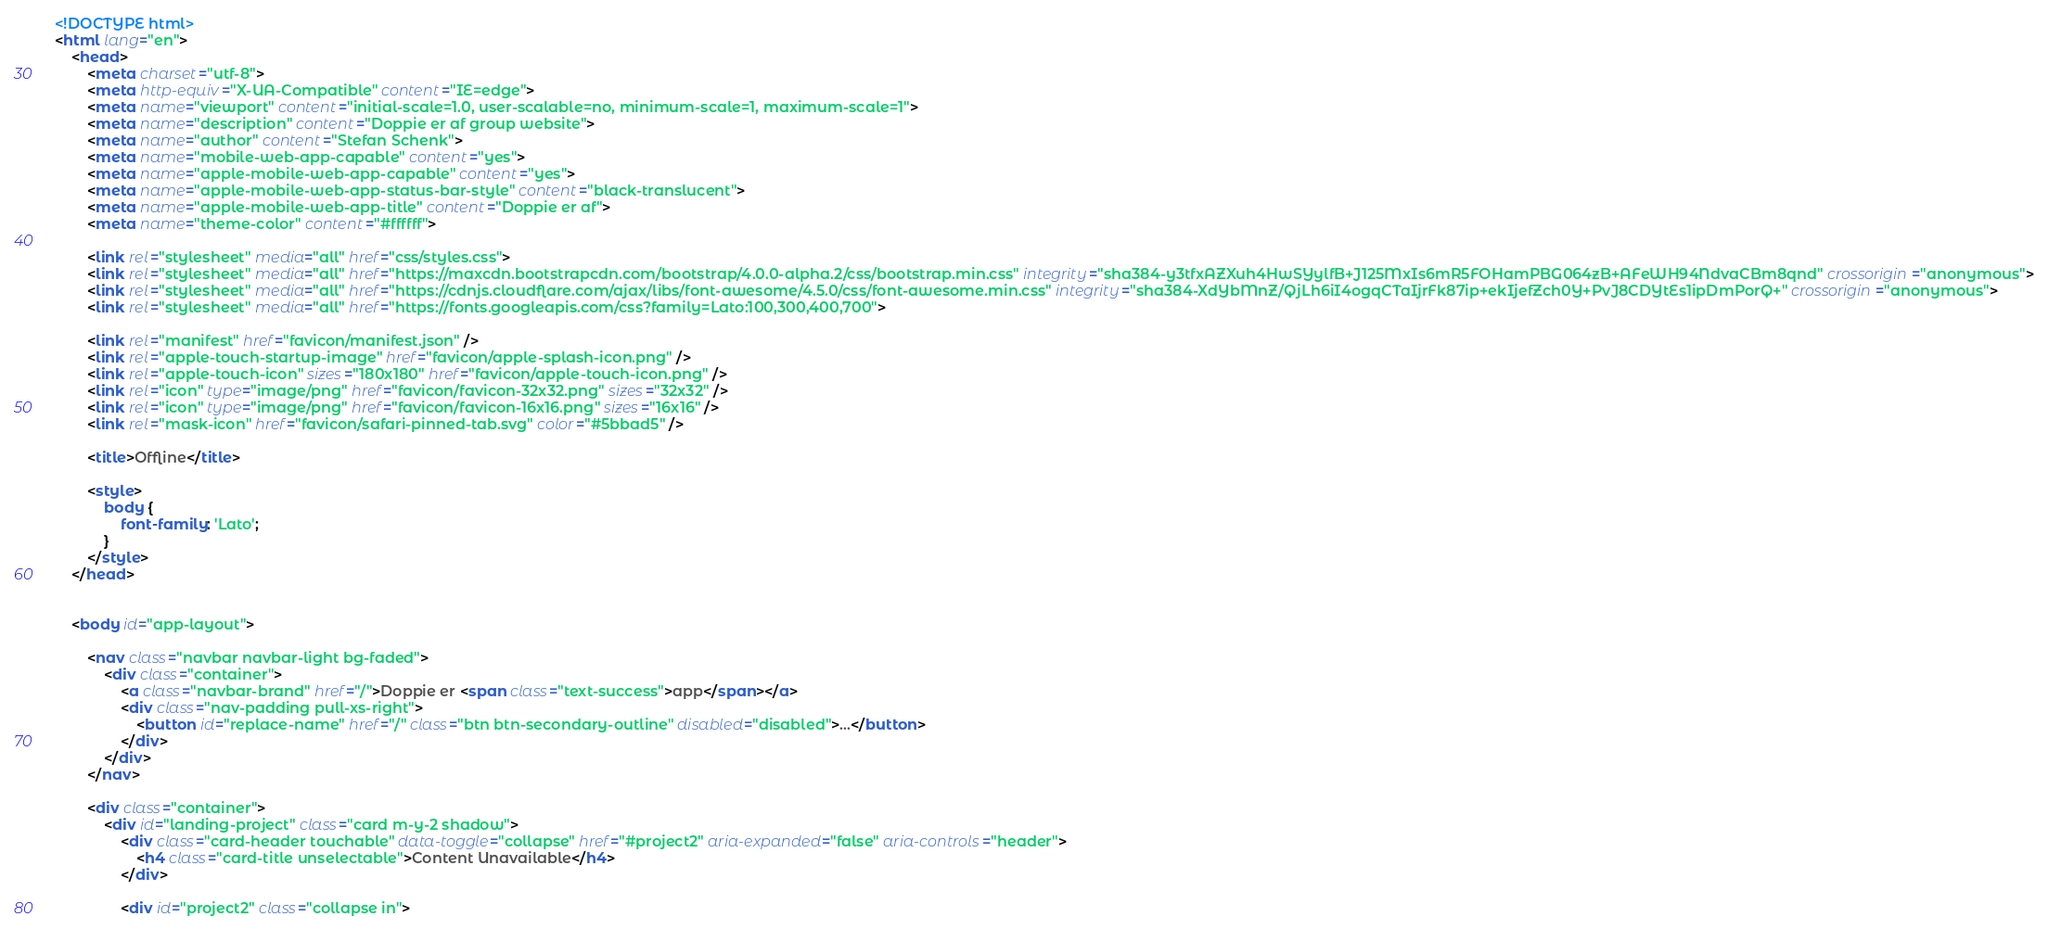Convert code to text. <code><loc_0><loc_0><loc_500><loc_500><_HTML_><!DOCTYPE html>
<html lang="en">
	<head>
		<meta charset="utf-8">
		<meta http-equiv="X-UA-Compatible" content="IE=edge">
		<meta name="viewport" content="initial-scale=1.0, user-scalable=no, minimum-scale=1, maximum-scale=1">
		<meta name="description" content="Doppie er af group website">
		<meta name="author" content="Stefan Schenk">
		<meta name="mobile-web-app-capable" content="yes">
		<meta name="apple-mobile-web-app-capable" content="yes">
		<meta name="apple-mobile-web-app-status-bar-style" content="black-translucent">
		<meta name="apple-mobile-web-app-title" content="Doppie er af">
		<meta name="theme-color" content="#ffffff">

		<link rel="stylesheet" media="all" href="css/styles.css">
		<link rel="stylesheet" media="all" href="https://maxcdn.bootstrapcdn.com/bootstrap/4.0.0-alpha.2/css/bootstrap.min.css" integrity="sha384-y3tfxAZXuh4HwSYylfB+J125MxIs6mR5FOHamPBG064zB+AFeWH94NdvaCBm8qnd" crossorigin="anonymous">
		<link rel="stylesheet" media="all" href="https://cdnjs.cloudflare.com/ajax/libs/font-awesome/4.5.0/css/font-awesome.min.css" integrity="sha384-XdYbMnZ/QjLh6iI4ogqCTaIjrFk87ip+ekIjefZch0Y+PvJ8CDYtEs1ipDmPorQ+" crossorigin="anonymous">
		<link rel="stylesheet" media="all" href="https://fonts.googleapis.com/css?family=Lato:100,300,400,700">

		<link rel="manifest" href="favicon/manifest.json" />
		<link rel="apple-touch-startup-image" href="favicon/apple-splash-icon.png" />
		<link rel="apple-touch-icon" sizes="180x180" href="favicon/apple-touch-icon.png" />
		<link rel="icon" type="image/png" href="favicon/favicon-32x32.png" sizes="32x32" />
		<link rel="icon" type="image/png" href="favicon/favicon-16x16.png" sizes="16x16" />
		<link rel="mask-icon" href="favicon/safari-pinned-tab.svg" color="#5bbad5" />

		<title>Offline</title>

		<style>
			body {
				font-family: 'Lato';
			}
		</style>
	</head>


	<body id="app-layout">

		<nav class="navbar navbar-light bg-faded">
			<div class="container">
				<a class="navbar-brand" href="/">Doppie er <span class="text-success">app</span></a>
				<div class="nav-padding pull-xs-right">
					<button id="replace-name" href="/" class="btn btn-secondary-outline" disabled="disabled">...</button>
				</div>
			</div>
		</nav>

		<div class="container">
			<div id="landing-project" class="card m-y-2 shadow">
				<div class="card-header touchable" data-toggle="collapse" href="#project2" aria-expanded="false" aria-controls="header">
					<h4 class="card-title unselectable">Content Unavailable</h4>
				</div>

				<div id="project2" class="collapse in"></code> 